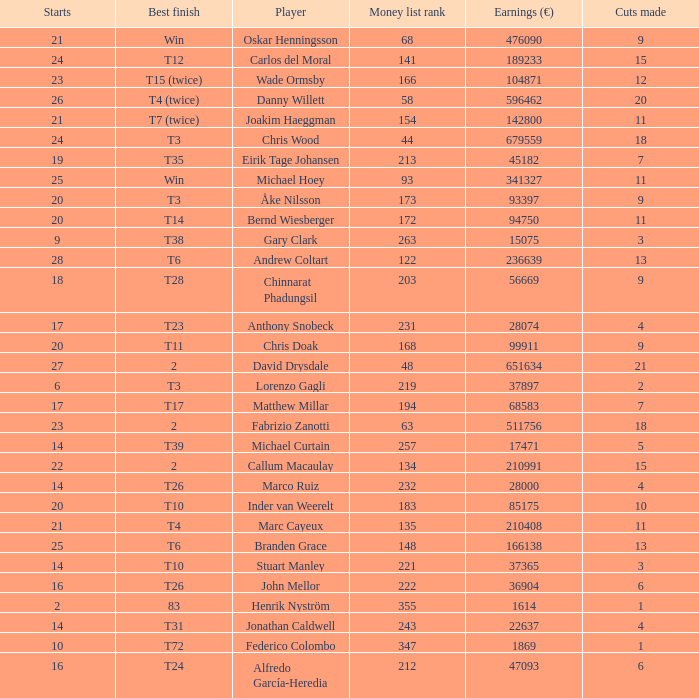How many earnings values are associated with players who had a best finish of T38? 1.0. 